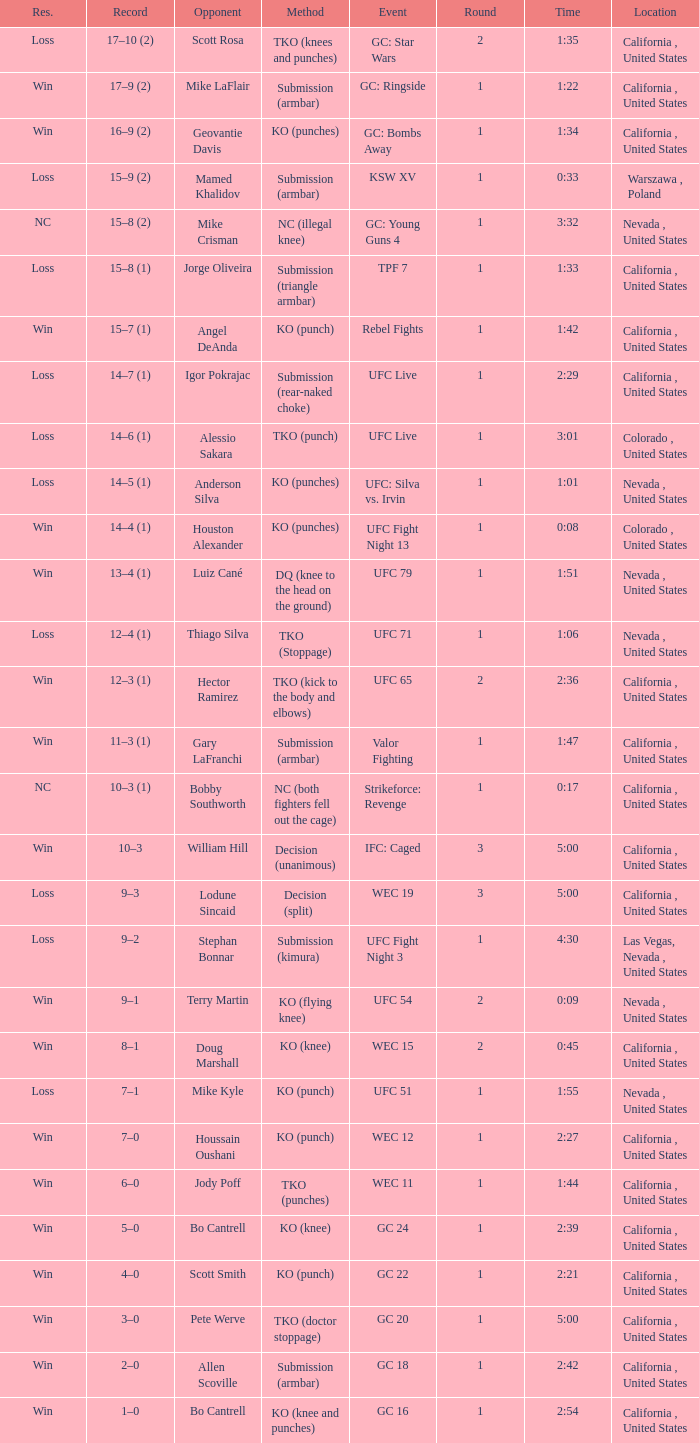What is the procedure where there is a decline with time 5:00? Decision (split). 